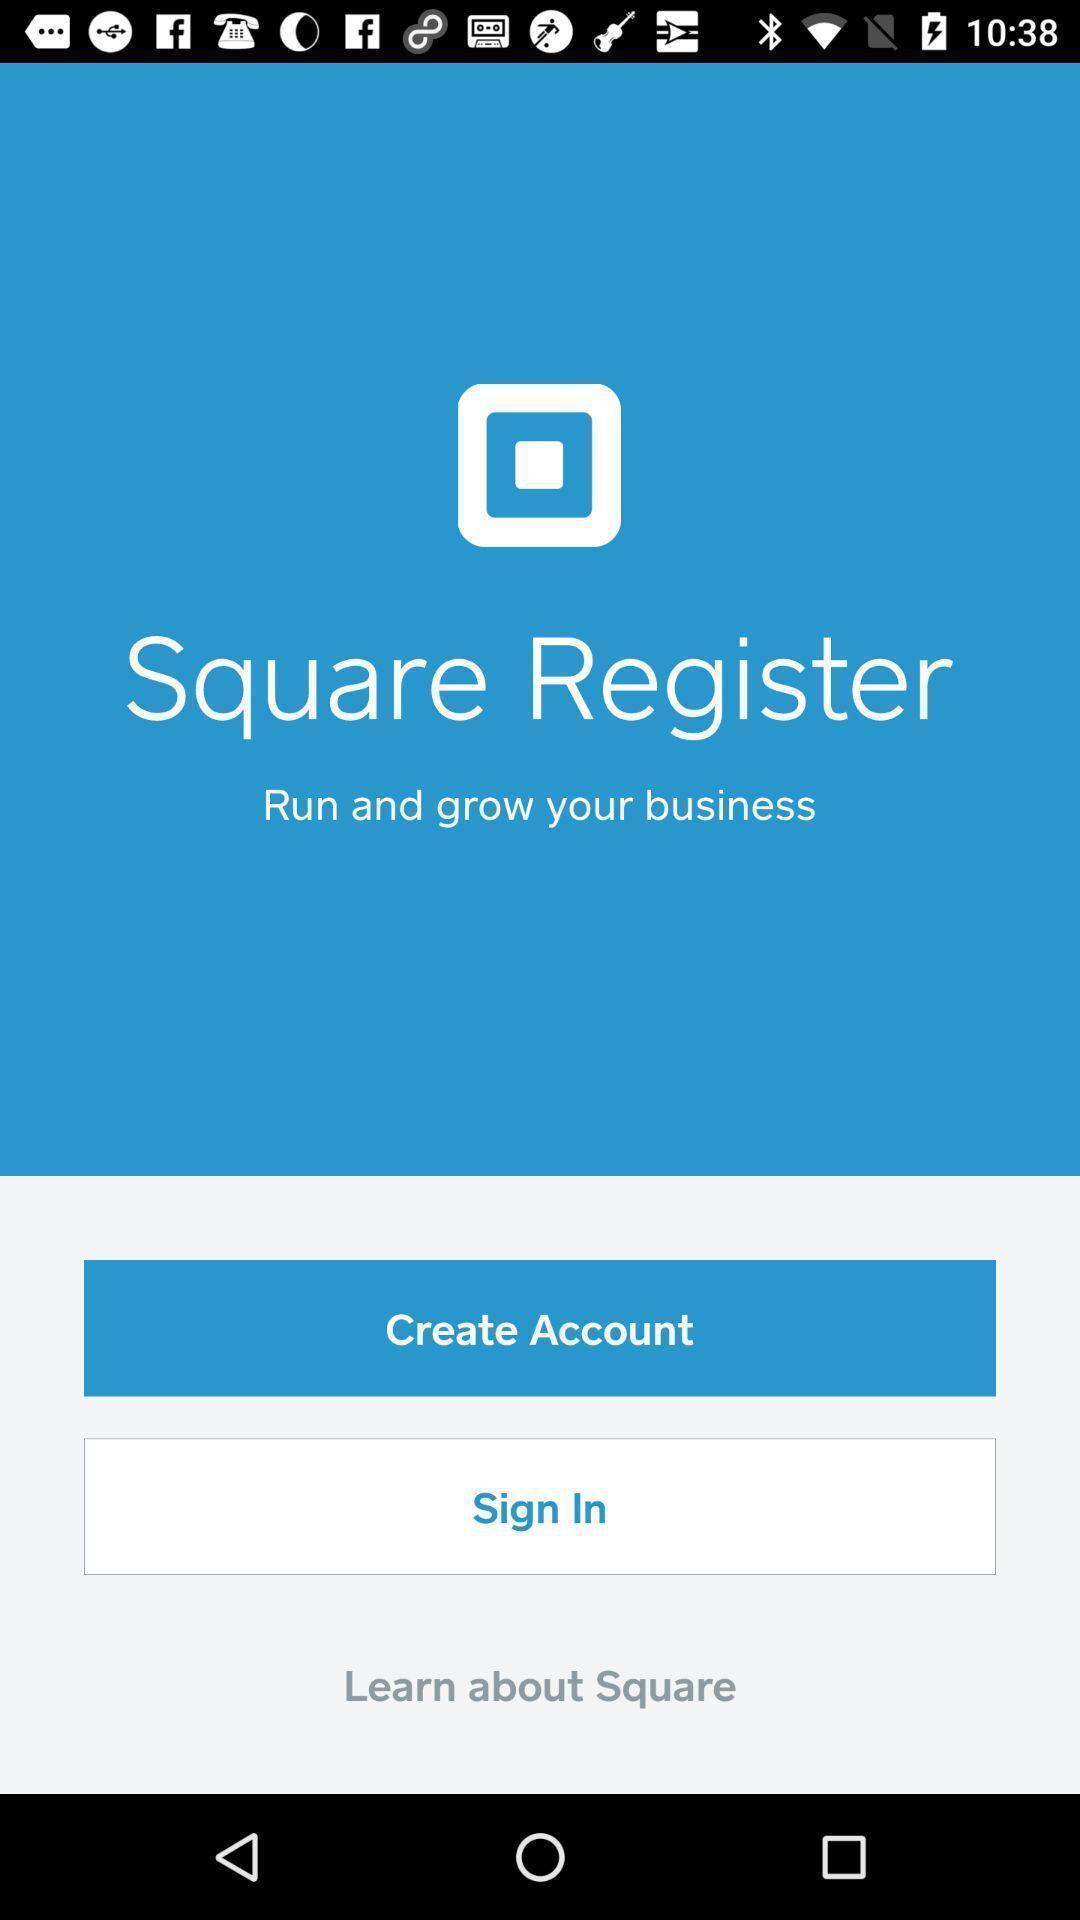Provide a description of this screenshot. Welcome page for a sales app. 